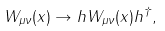Convert formula to latex. <formula><loc_0><loc_0><loc_500><loc_500>W _ { \mu \nu } ( x ) \rightarrow h W _ { \mu \nu } ( x ) h ^ { \dagger } ,</formula> 